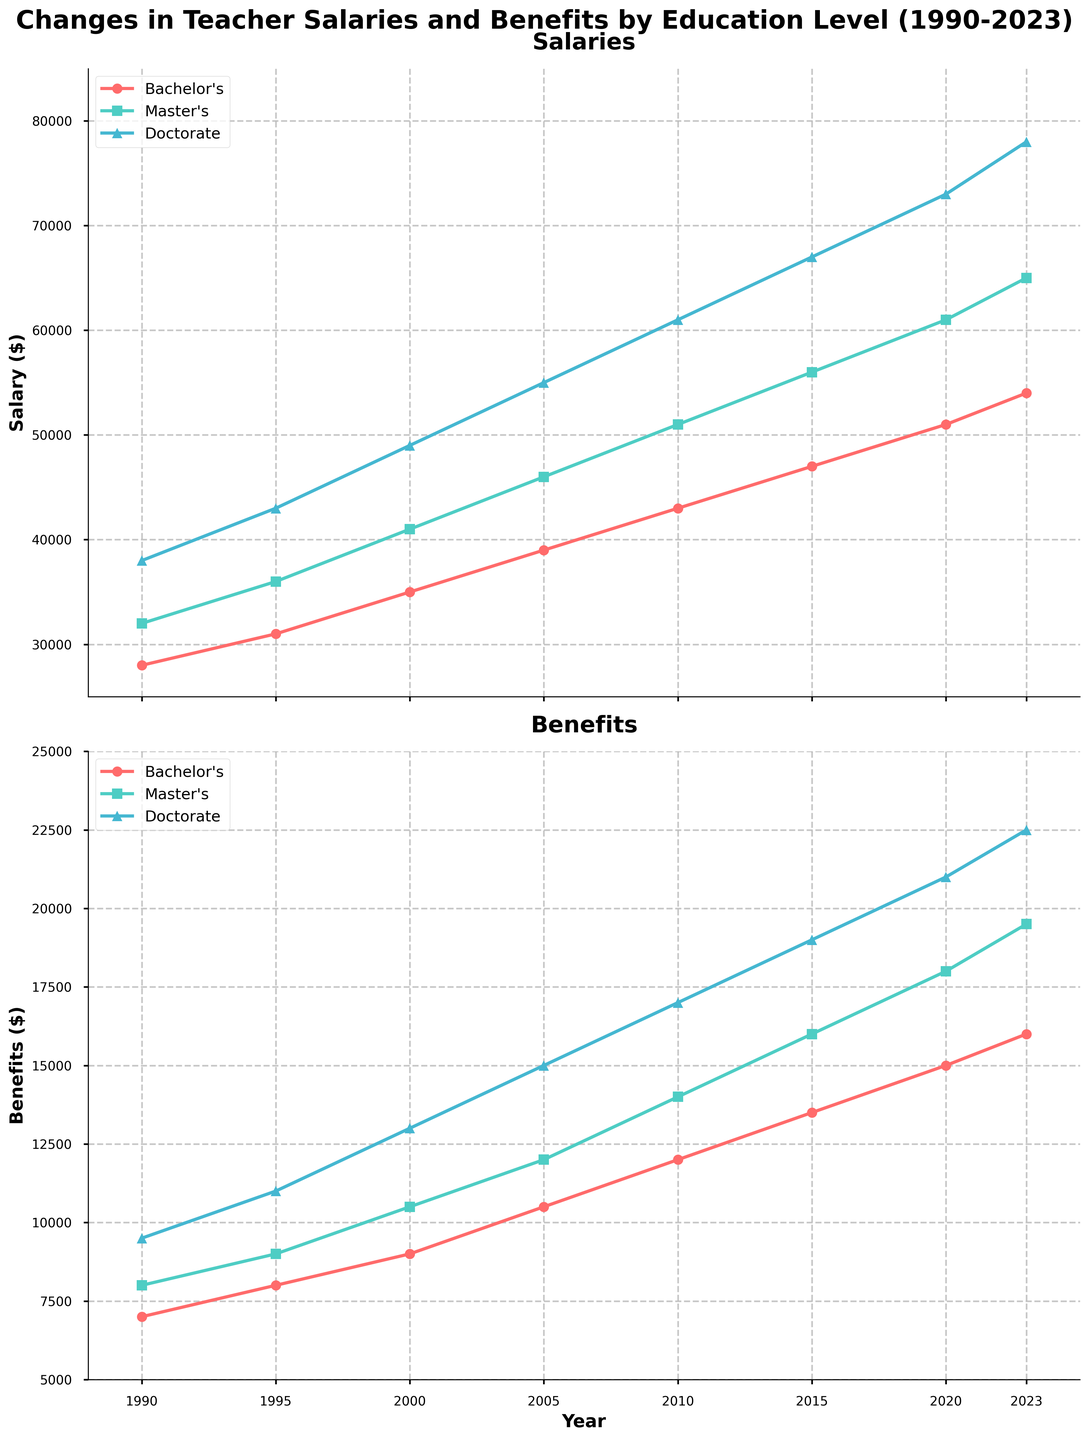What's the average salary of a teacher with a Doctorate degree across the provided years? To find the average salary for teachers with a Doctorate degree, sum all the Doctorate salaries and divide by the number of years given. The sum is 38000 + 43000 + 49000 + 55000 + 61000 + 67000 + 73000 + 78000 = 464000. There are 8 years given, so the average is 464000 / 8 = 58000.
Answer: 58000 Which education level sees the highest increase in benefits from 1990 to 2023? Compare the increase in benefits for each education level. Bachelor's benefits increased from 7000 to 16000 (an increase of 9000), Master's increased from 8000 to 19500 (an increase of 11500), and Doctorate increased from 9500 to 22500 (an increase of 13000). The Doctorate level sees the highest increase.
Answer: Doctorate In which year did teachers with a Bachelor's degree see the highest salary increase compared to the previous year? Compare the salary increments for Bachelor's degree teachers year-over-year: 1995-1990 (31000-28000=3000), 2000-1995 (35000-31000=4000), 2005-2000 (39000-35000=4000), 2010-2005 (43000-39000=4000), 2015-2010 (47000-43000=4000), 2020-2015 (51000-47000=4000), 2023-2020 (54000-51000=3000). The highest increase (4000) is tied among several periods (2000, 2005, 2010, 2015, and 2020).
Answer: 2000, 2005, 2010, 2015, and 2020 By how much did the salary for a Master's degree teacher change from 1990 to 2023? Calculate the difference in salaries for Master's degree teachers between 1990 and 2023: 65000 - 32000 = 33000.
Answer: 33000 In what year did the benefits for Bachelor's degree teachers first exceed 10,000? Look at the benefits values for Bachelor's degrees over the years: the first year it exceeds 10,000 is 2005 (10500).
Answer: 2005 